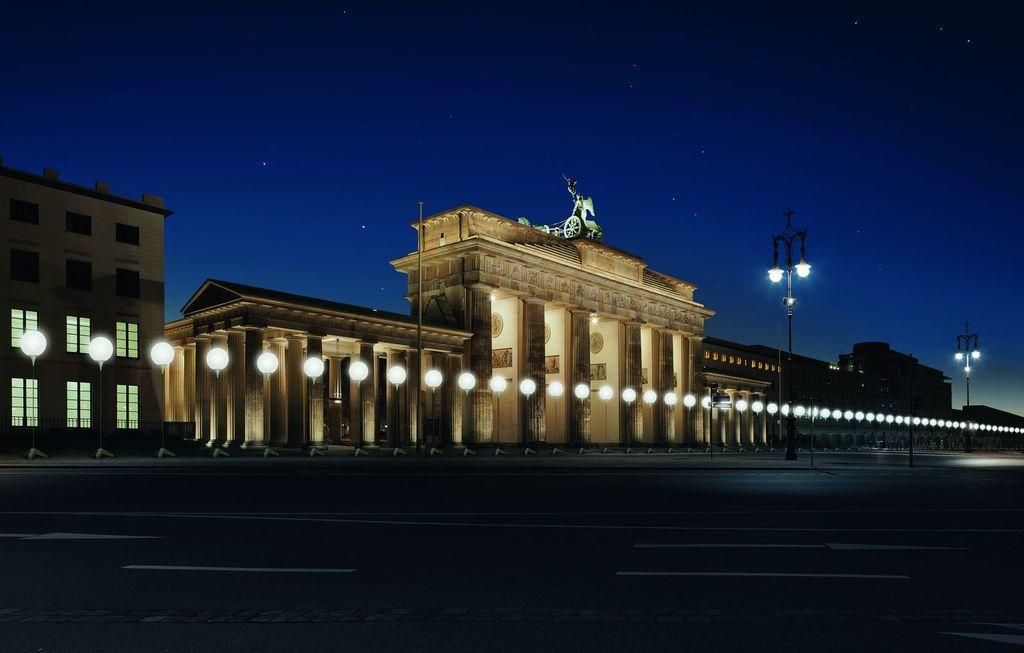Please provide a concise description of this image. At the bottom of the image there is a road. Behind the road there is a footpath with many poles and lamps to it. Behind the poles there is a building with walls, pillars, sculptures and there is a statue on the building. And on the left side of the image there is a building with walls and windows. At the top of the image there is a sky with stars. 